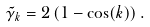Convert formula to latex. <formula><loc_0><loc_0><loc_500><loc_500>\tilde { \gamma } _ { k } = 2 \left ( 1 - \cos ( k ) \right ) .</formula> 